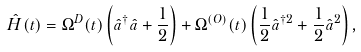Convert formula to latex. <formula><loc_0><loc_0><loc_500><loc_500>\hat { H } ( t ) = \Omega ^ { D } ( t ) \left ( \hat { a } ^ { \dagger } \hat { a } + \frac { 1 } { 2 } \right ) + \Omega ^ { ( O ) } ( t ) \left ( \frac { 1 } { 2 } \hat { a } ^ { \dagger 2 } + \frac { 1 } { 2 } \hat { a } ^ { 2 } \right ) ,</formula> 